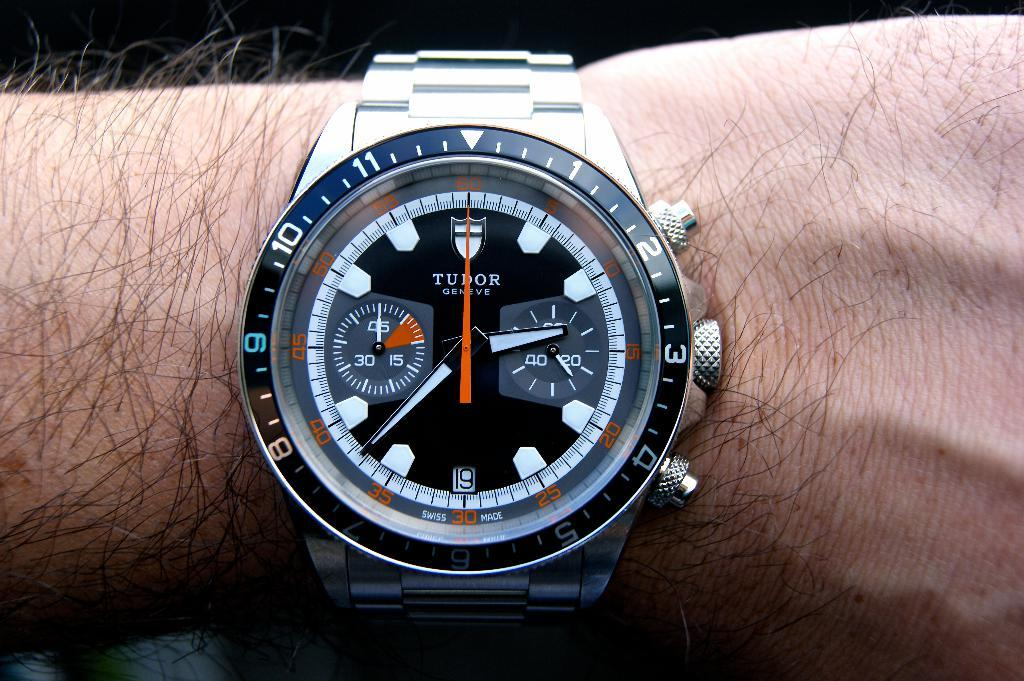What part of a person's body is visible in the image? There is a person's hand in the image. What is the person's hand holding or wearing? The person's hand is wearing a watch. How many rings can be seen on the person's hand in the image? There are no rings visible on the person's hand in the image. Are there any giants present in the image? There are no giants present in the image. 